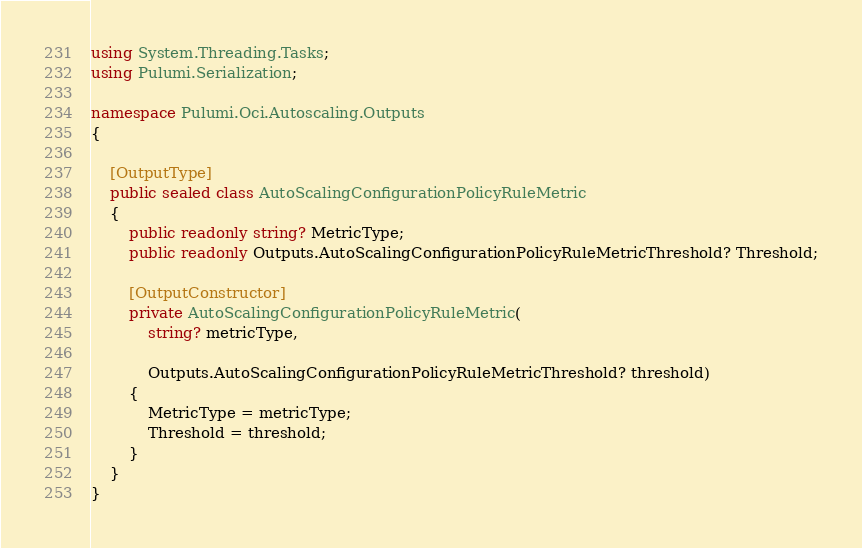Convert code to text. <code><loc_0><loc_0><loc_500><loc_500><_C#_>using System.Threading.Tasks;
using Pulumi.Serialization;

namespace Pulumi.Oci.Autoscaling.Outputs
{

    [OutputType]
    public sealed class AutoScalingConfigurationPolicyRuleMetric
    {
        public readonly string? MetricType;
        public readonly Outputs.AutoScalingConfigurationPolicyRuleMetricThreshold? Threshold;

        [OutputConstructor]
        private AutoScalingConfigurationPolicyRuleMetric(
            string? metricType,

            Outputs.AutoScalingConfigurationPolicyRuleMetricThreshold? threshold)
        {
            MetricType = metricType;
            Threshold = threshold;
        }
    }
}
</code> 